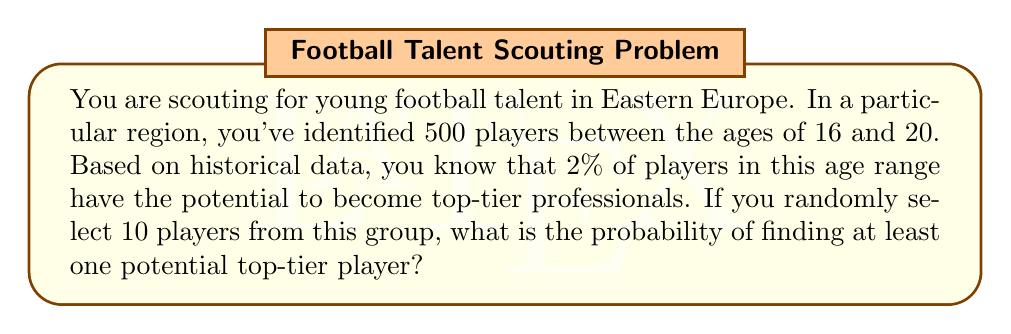Can you answer this question? To solve this problem, we'll use the concept of probability and the binomial distribution.

1) First, let's define our events:
   Let A be the event of finding at least one potential top-tier player.

2) It's easier to calculate the probability of not finding any top-tier players and then subtract that from 1.

3) The probability of a player being a potential top-tier player is 2% or 0.02.

4) The probability of a player not being a potential top-tier player is 1 - 0.02 = 0.98.

5) For all 10 selected players to not be potential top-tier players, each selection must not be a top-tier player.

6) The probability of this happening is:

   $$(0.98)^{10}$$

7) Therefore, the probability of finding at least one potential top-tier player is:

   $$P(A) = 1 - (0.98)^{10}$$

8) Let's calculate this:

   $$P(A) = 1 - (0.98)^{10}$$
   $$    = 1 - 0.8179$$
   $$    = 0.1821$$

9) Converting to a percentage:

   $$0.1821 * 100 = 18.21\%$$

Thus, the probability of finding at least one potential top-tier player when randomly selecting 10 players is approximately 18.21%.
Answer: The probability of finding at least one potential top-tier player when randomly selecting 10 players is approximately 18.21%. 